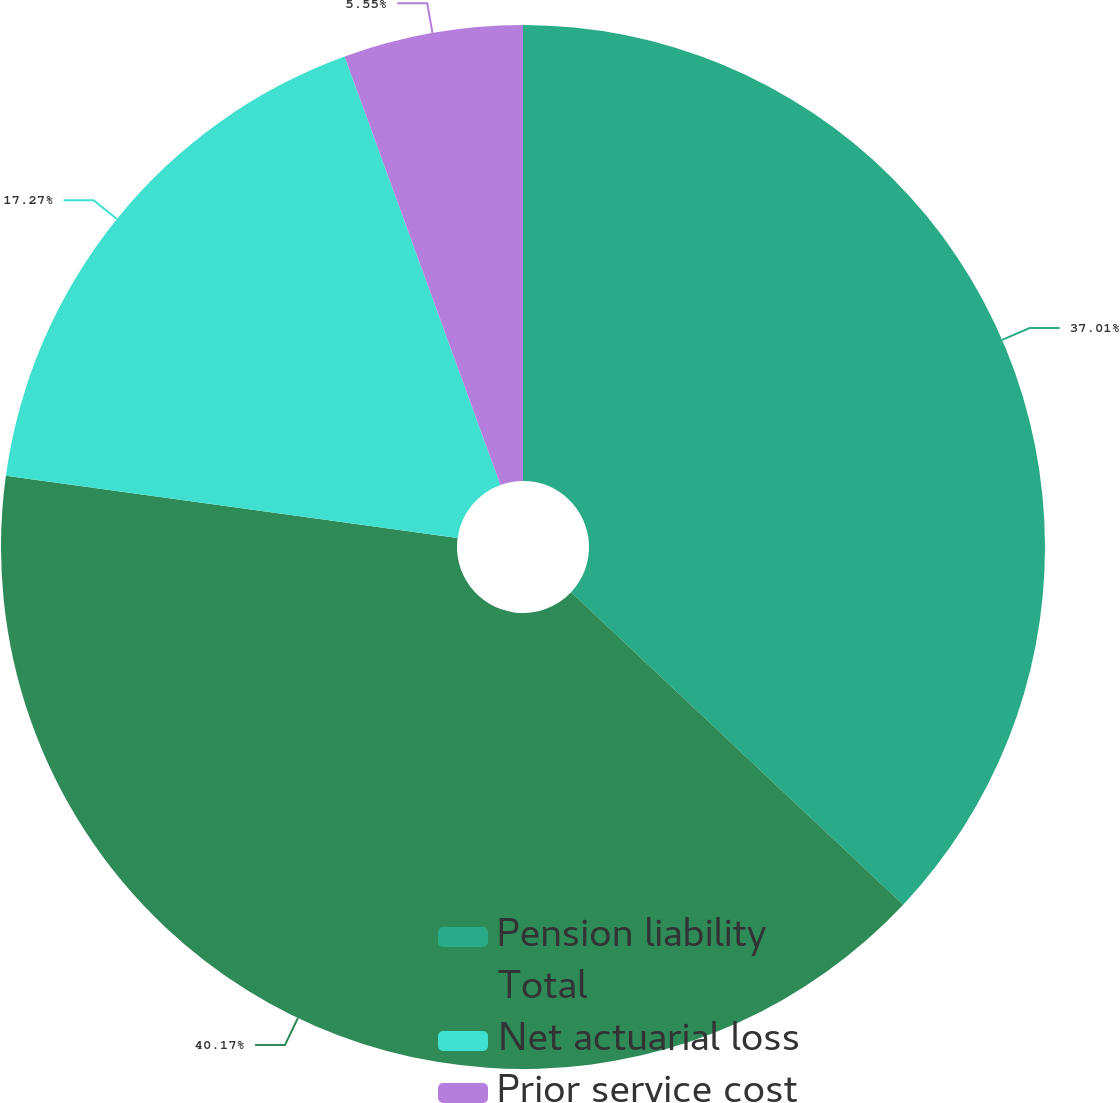Convert chart. <chart><loc_0><loc_0><loc_500><loc_500><pie_chart><fcel>Pension liability<fcel>Total<fcel>Net actuarial loss<fcel>Prior service cost<nl><fcel>37.01%<fcel>40.16%<fcel>17.27%<fcel>5.55%<nl></chart> 